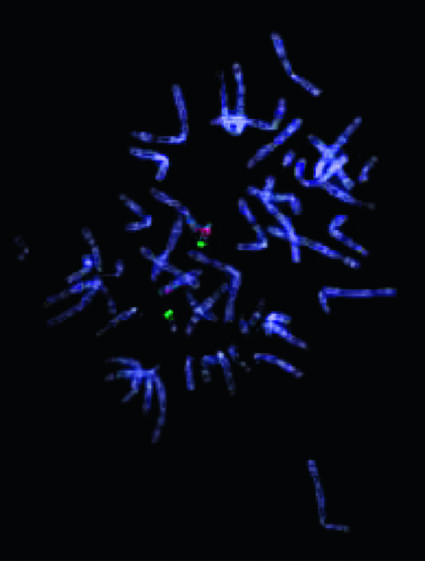what does this abnormality give rise to?
Answer the question using a single word or phrase. The 22q112 deletion syndrome 